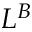<formula> <loc_0><loc_0><loc_500><loc_500>L ^ { B }</formula> 